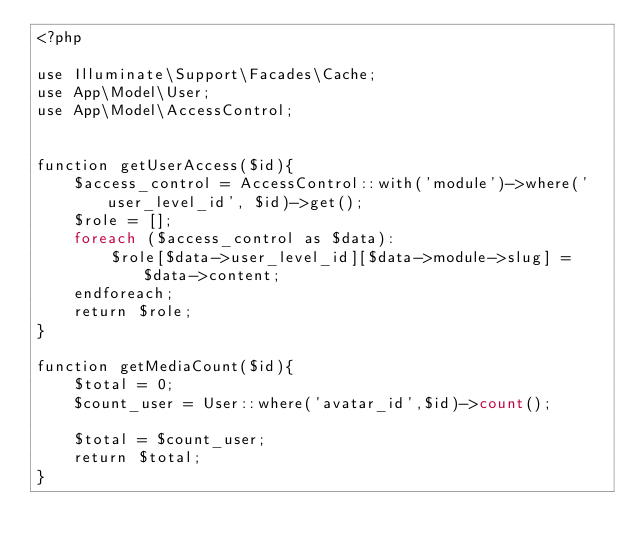<code> <loc_0><loc_0><loc_500><loc_500><_PHP_><?php

use Illuminate\Support\Facades\Cache;
use App\Model\User;
use App\Model\AccessControl;


function getUserAccess($id){
	$access_control = AccessControl::with('module')->where('user_level_id', $id)->get();
	$role = [];
	foreach ($access_control as $data):
		$role[$data->user_level_id][$data->module->slug] = $data->content;
	endforeach;
	return $role;
}

function getMediaCount($id){
	$total = 0;
	$count_user = User::where('avatar_id',$id)->count();
		
	$total = $count_user; 
	return $total;
}
</code> 